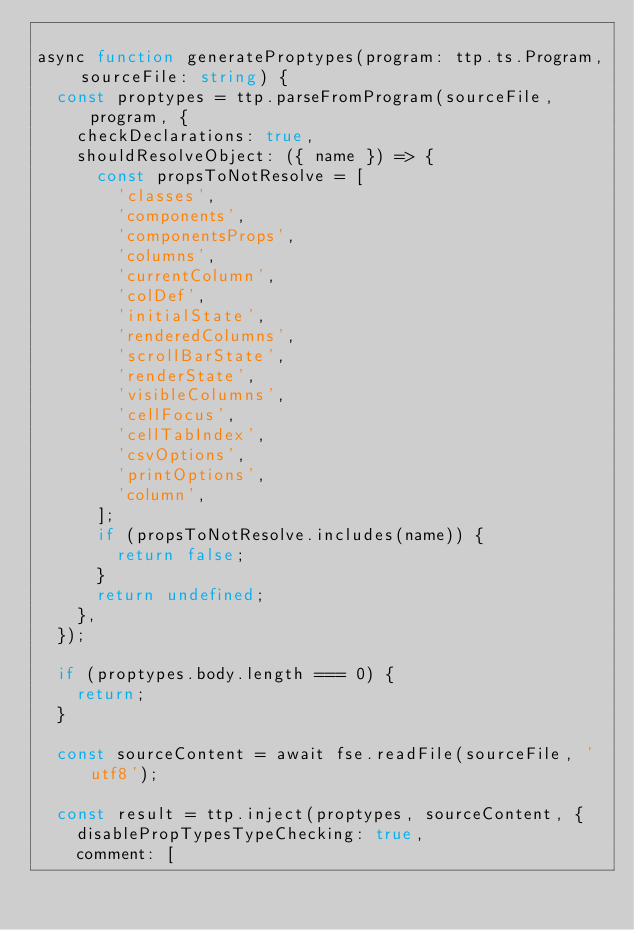Convert code to text. <code><loc_0><loc_0><loc_500><loc_500><_TypeScript_>
async function generateProptypes(program: ttp.ts.Program, sourceFile: string) {
  const proptypes = ttp.parseFromProgram(sourceFile, program, {
    checkDeclarations: true,
    shouldResolveObject: ({ name }) => {
      const propsToNotResolve = [
        'classes',
        'components',
        'componentsProps',
        'columns',
        'currentColumn',
        'colDef',
        'initialState',
        'renderedColumns',
        'scrollBarState',
        'renderState',
        'visibleColumns',
        'cellFocus',
        'cellTabIndex',
        'csvOptions',
        'printOptions',
        'column',
      ];
      if (propsToNotResolve.includes(name)) {
        return false;
      }
      return undefined;
    },
  });

  if (proptypes.body.length === 0) {
    return;
  }

  const sourceContent = await fse.readFile(sourceFile, 'utf8');

  const result = ttp.inject(proptypes, sourceContent, {
    disablePropTypesTypeChecking: true,
    comment: [</code> 